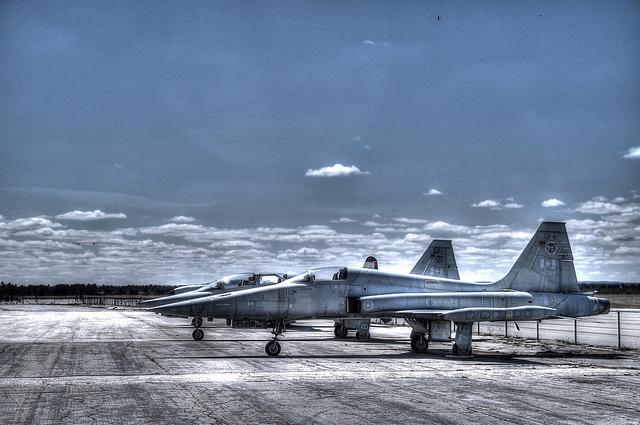What size is the jet on the right?
Write a very short answer. Large. Do the planes have propellers?
Quick response, please. No. What direction are the planes facing?
Quick response, please. Left. 